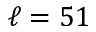<formula> <loc_0><loc_0><loc_500><loc_500>\ell = 5 1</formula> 